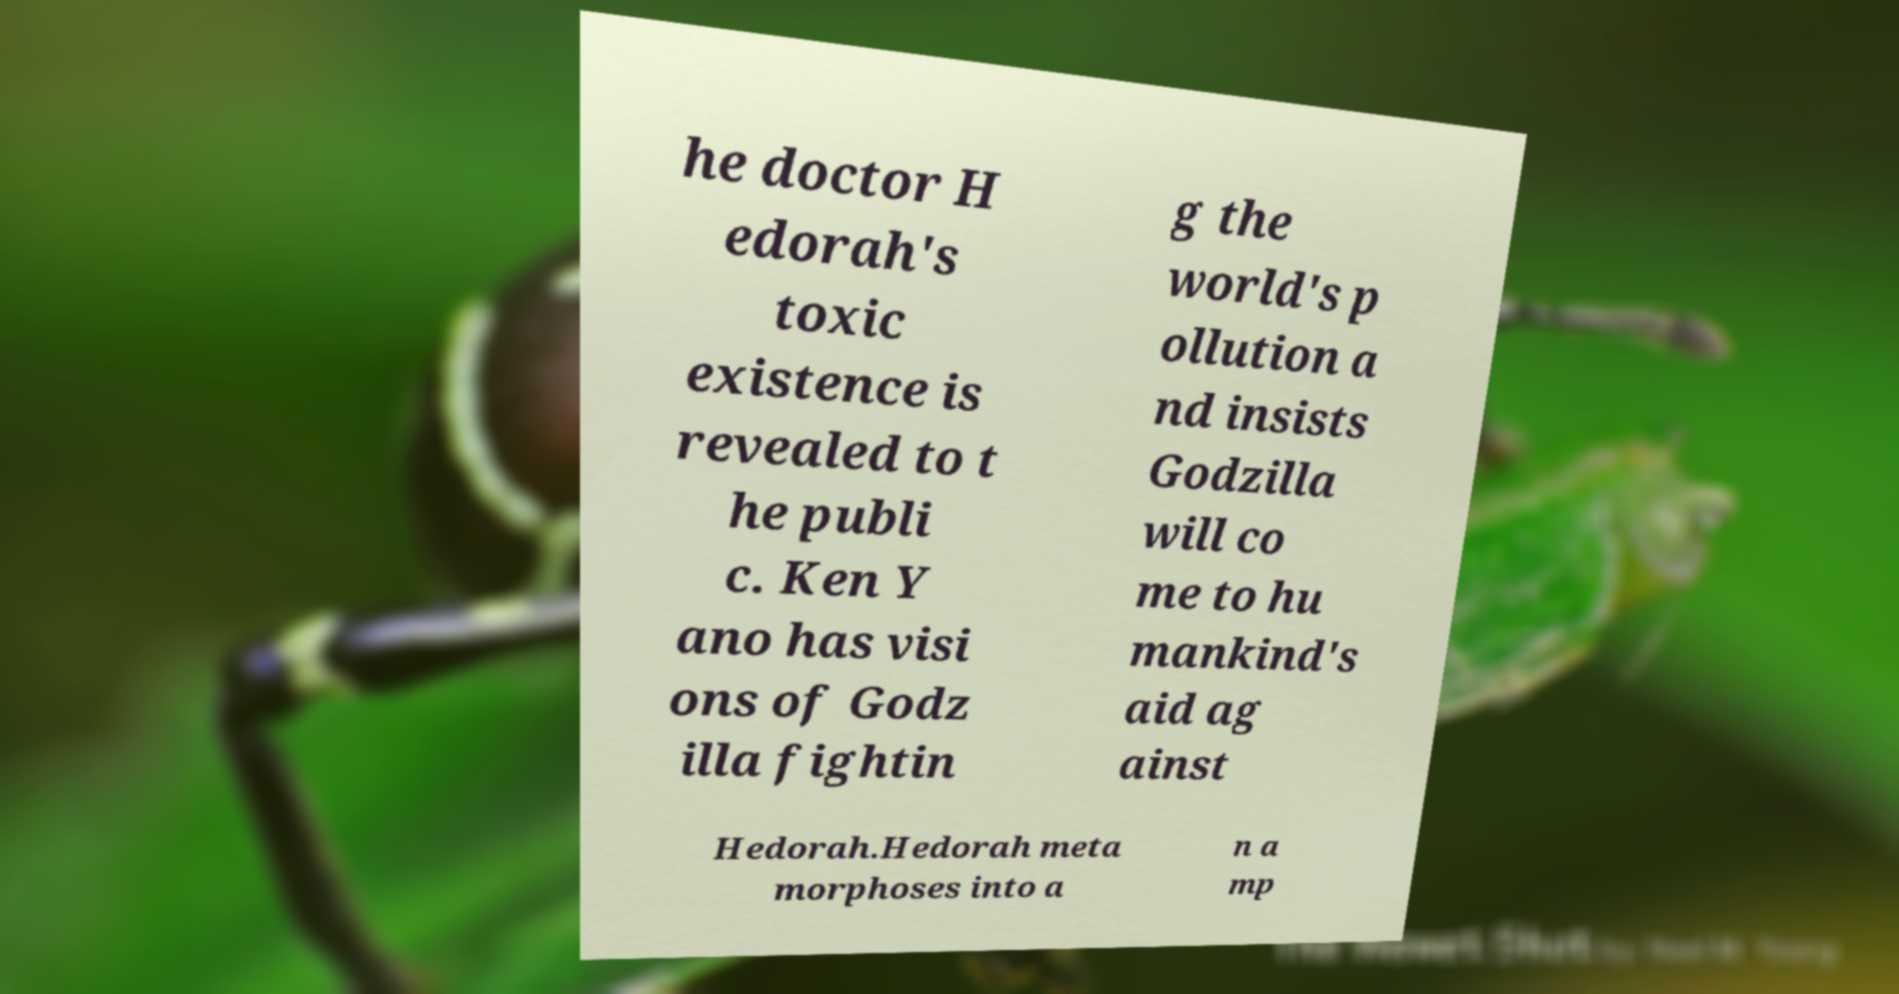Could you extract and type out the text from this image? he doctor H edorah's toxic existence is revealed to t he publi c. Ken Y ano has visi ons of Godz illa fightin g the world's p ollution a nd insists Godzilla will co me to hu mankind's aid ag ainst Hedorah.Hedorah meta morphoses into a n a mp 